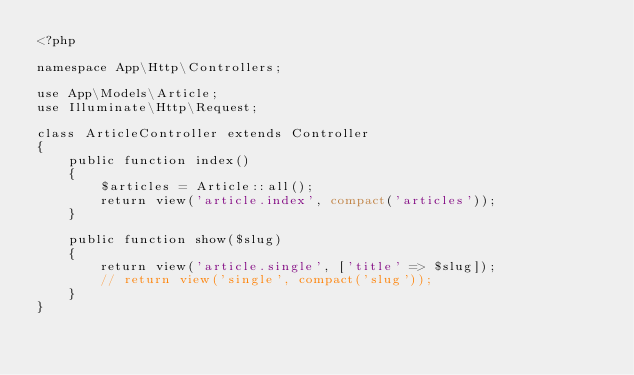Convert code to text. <code><loc_0><loc_0><loc_500><loc_500><_PHP_><?php

namespace App\Http\Controllers;

use App\Models\Article;
use Illuminate\Http\Request;

class ArticleController extends Controller
{
    public function index()
    {
        $articles = Article::all();
        return view('article.index', compact('articles'));
    }

    public function show($slug)
    {
        return view('article.single', ['title' => $slug]);
        // return view('single', compact('slug'));
    }
}
</code> 